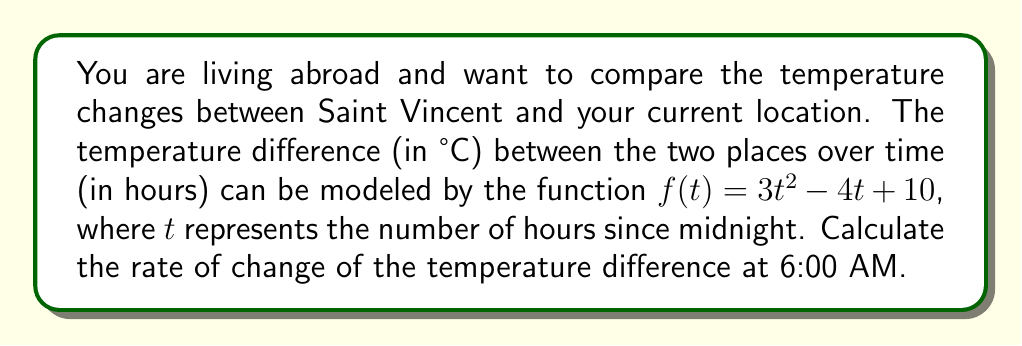Could you help me with this problem? To solve this problem, we need to follow these steps:

1) First, we need to find the derivative of the given function $f(t) = 3t^2 - 4t + 10$.

   Using the power rule and the constant rule of differentiation:
   
   $f'(t) = 6t - 4$

2) Now that we have the derivative, we need to evaluate it at 6:00 AM, which is 6 hours after midnight.

3) Substituting $t = 6$ into the derivative function:

   $f'(6) = 6(6) - 4$
   
   $f'(6) = 36 - 4 = 32$

4) The units of the derivative will be °C/hour, as it represents the rate of change of temperature difference with respect to time.
Answer: $32$ °C/hour 